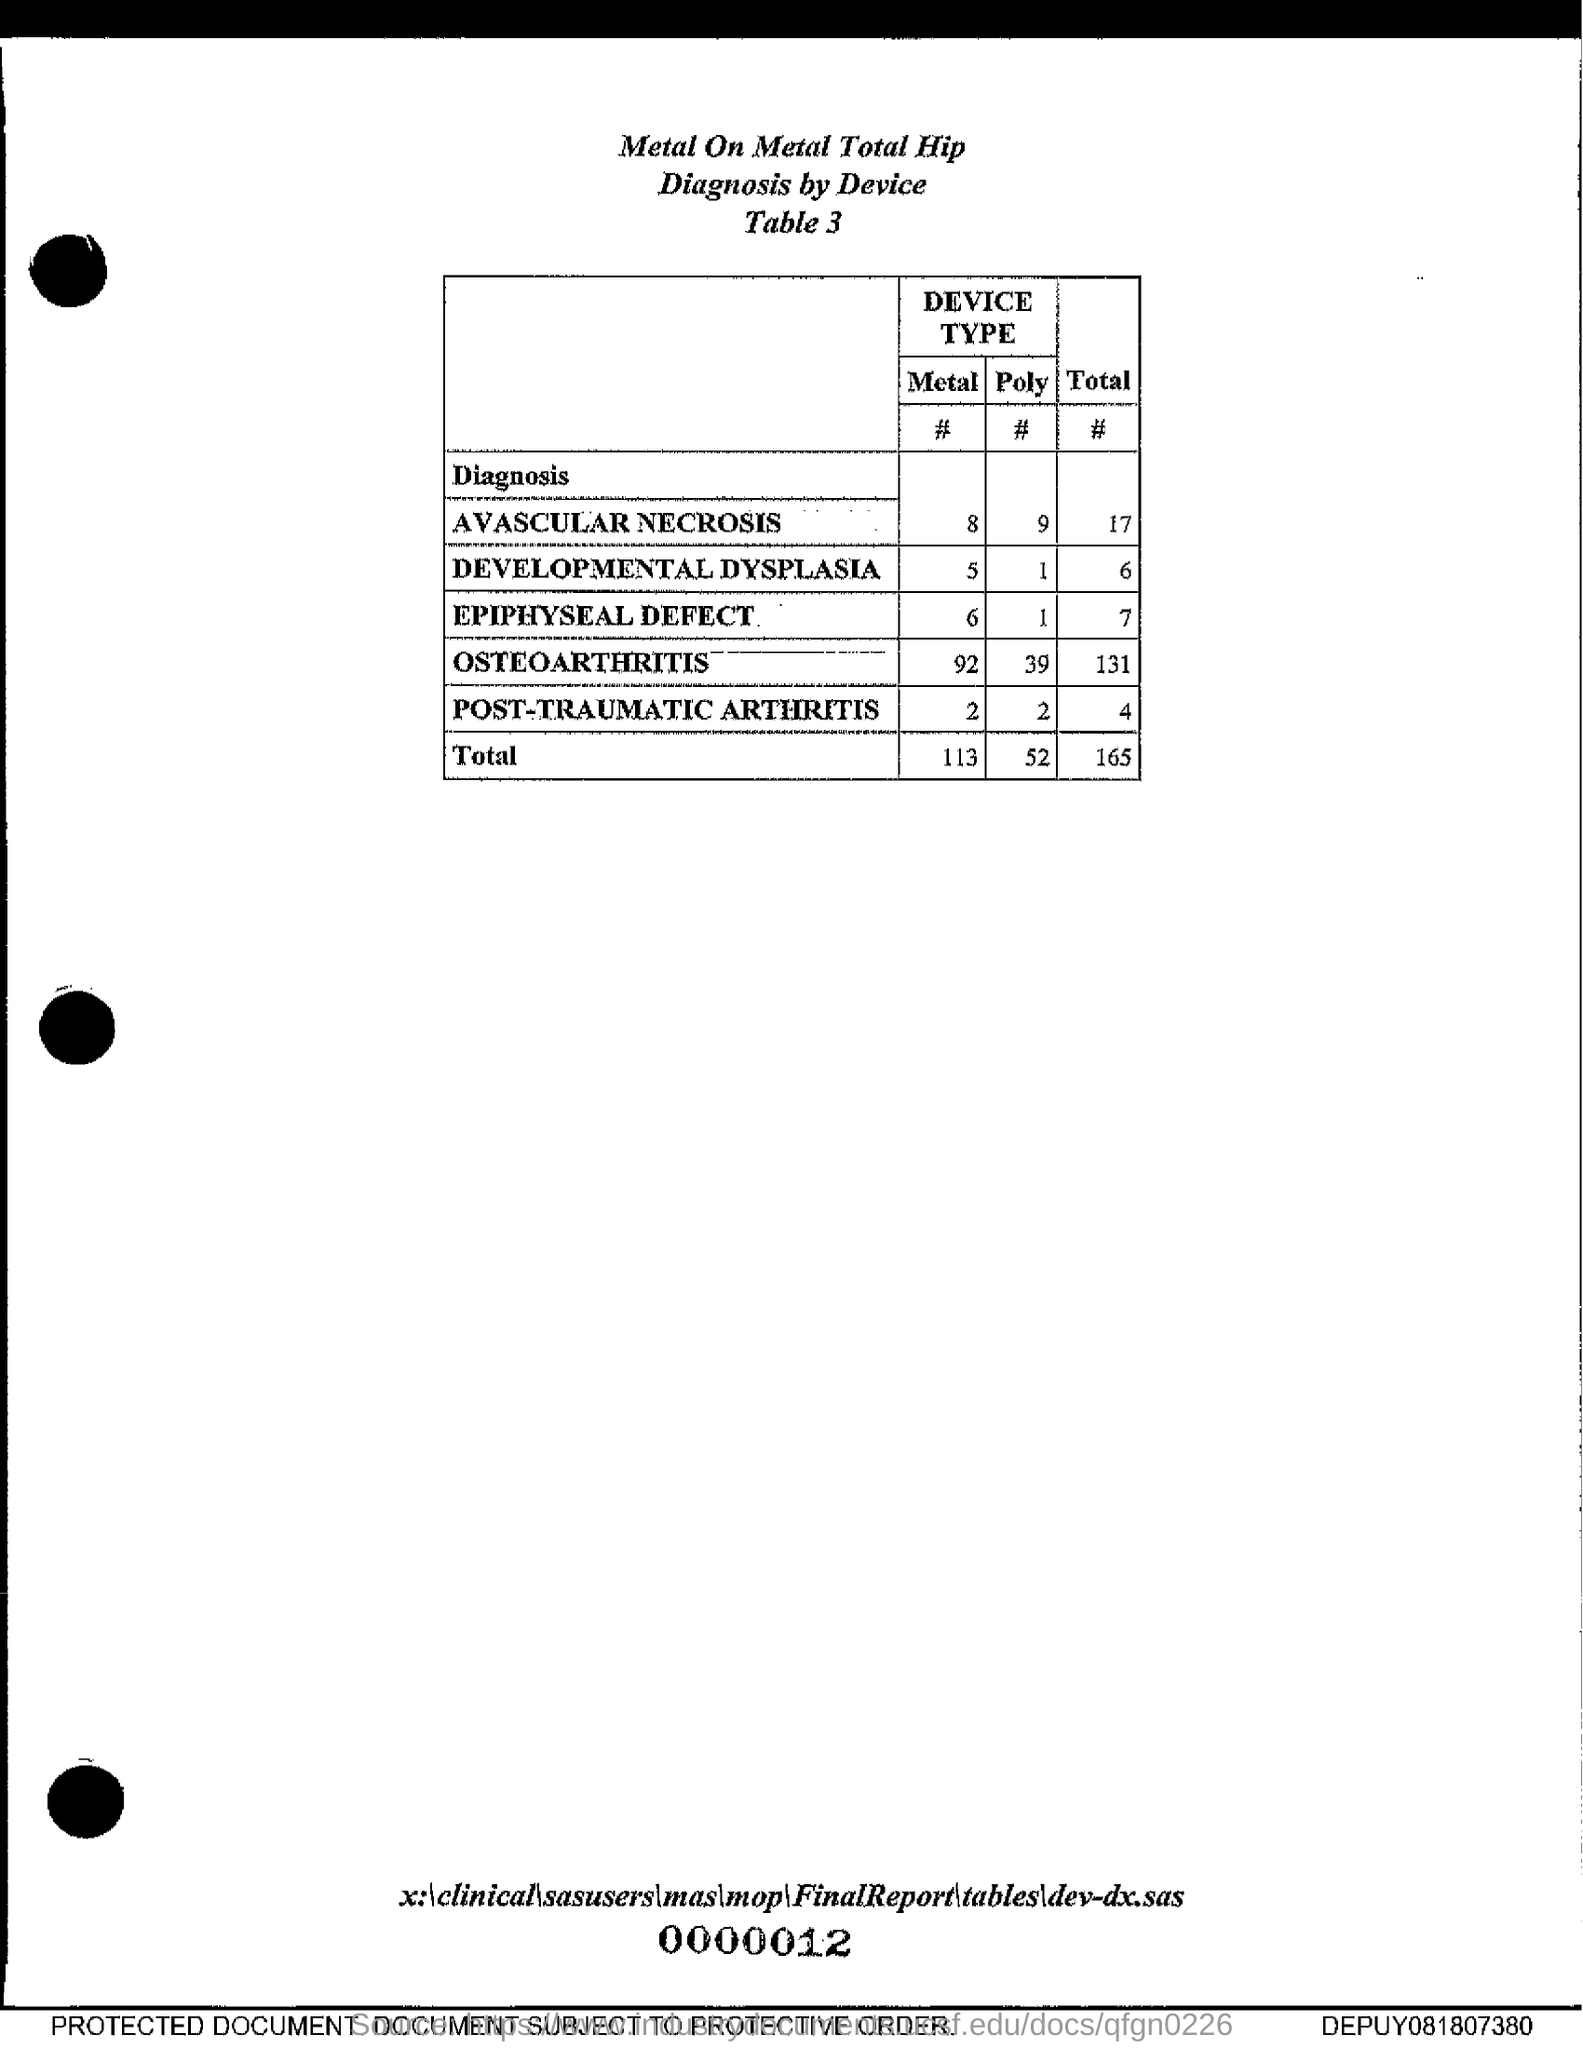Draw attention to some important aspects in this diagram. There are eight metal devices used for avascular necrosis. The total number of epiphyseal defects is 7. The title given is "Metal On Metal Total Hip Diagnosis by Device. 